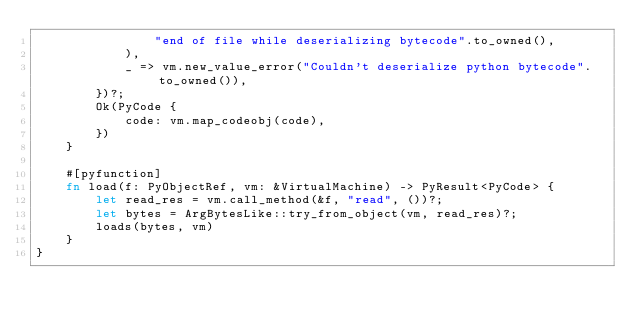<code> <loc_0><loc_0><loc_500><loc_500><_Rust_>                "end of file while deserializing bytecode".to_owned(),
            ),
            _ => vm.new_value_error("Couldn't deserialize python bytecode".to_owned()),
        })?;
        Ok(PyCode {
            code: vm.map_codeobj(code),
        })
    }

    #[pyfunction]
    fn load(f: PyObjectRef, vm: &VirtualMachine) -> PyResult<PyCode> {
        let read_res = vm.call_method(&f, "read", ())?;
        let bytes = ArgBytesLike::try_from_object(vm, read_res)?;
        loads(bytes, vm)
    }
}
</code> 